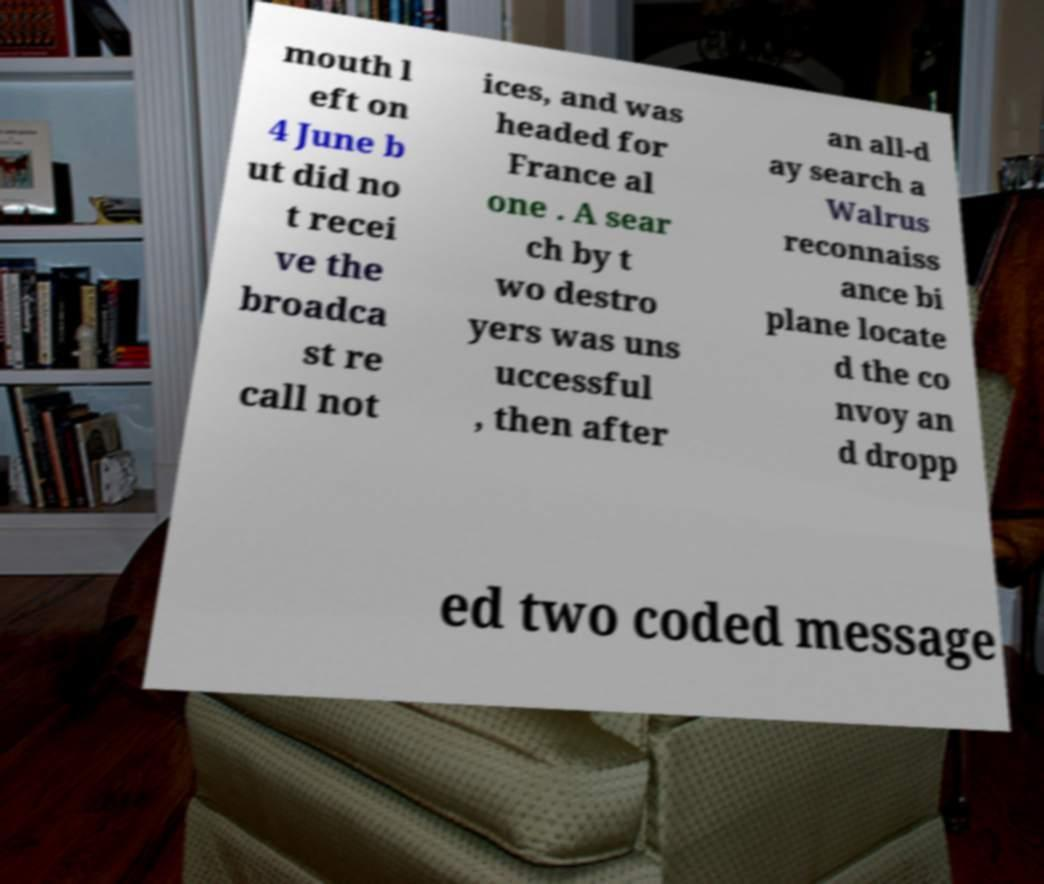Please read and relay the text visible in this image. What does it say? mouth l eft on 4 June b ut did no t recei ve the broadca st re call not ices, and was headed for France al one . A sear ch by t wo destro yers was uns uccessful , then after an all-d ay search a Walrus reconnaiss ance bi plane locate d the co nvoy an d dropp ed two coded message 